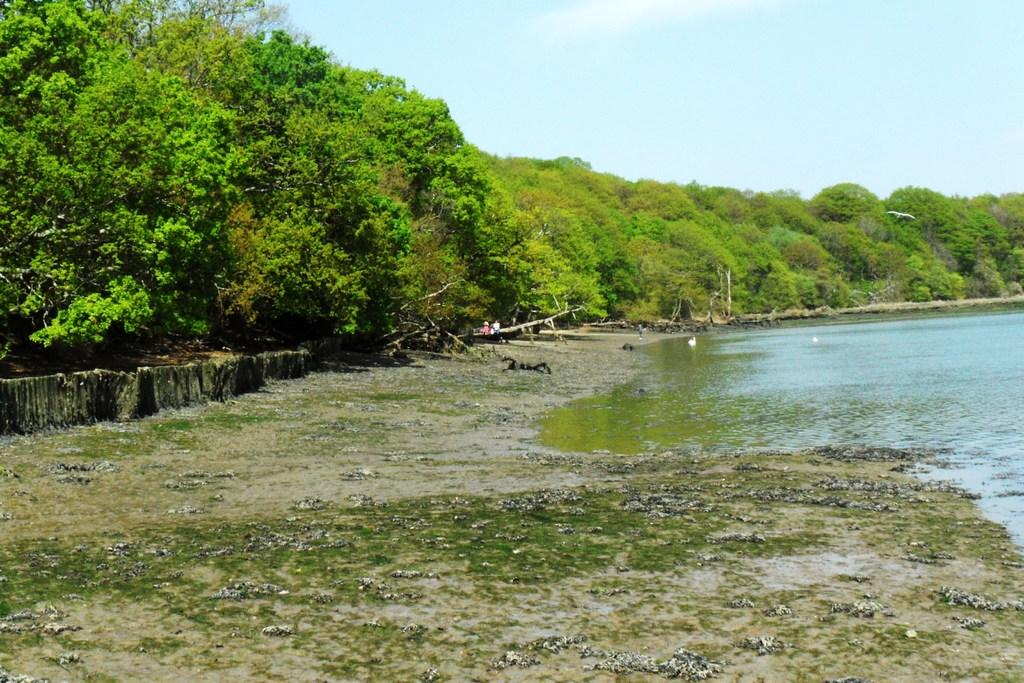What is the main feature of the image? The main feature of the image is a water surface. What can be seen surrounding the water surface? There are plenty of trees around the water surface in the image. Can you describe the environment in the image? The environment in the image consists of a water surface surrounded by trees. What type of holiday is being celebrated near the water surface in the image? There is no indication of a holiday being celebrated in the image; it only features a water surface surrounded by trees. 